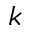Convert formula to latex. <formula><loc_0><loc_0><loc_500><loc_500>k</formula> 